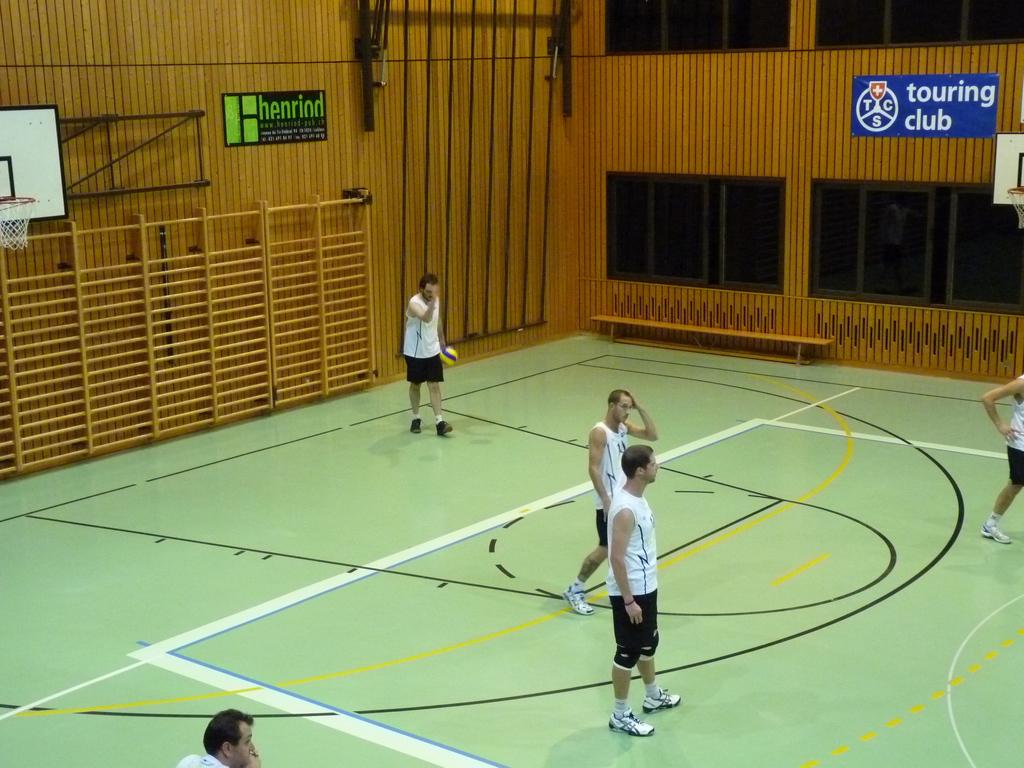What kind of club is this?
Ensure brevity in your answer.  Touring. What is the company written in green?
Make the answer very short. Henrind. 